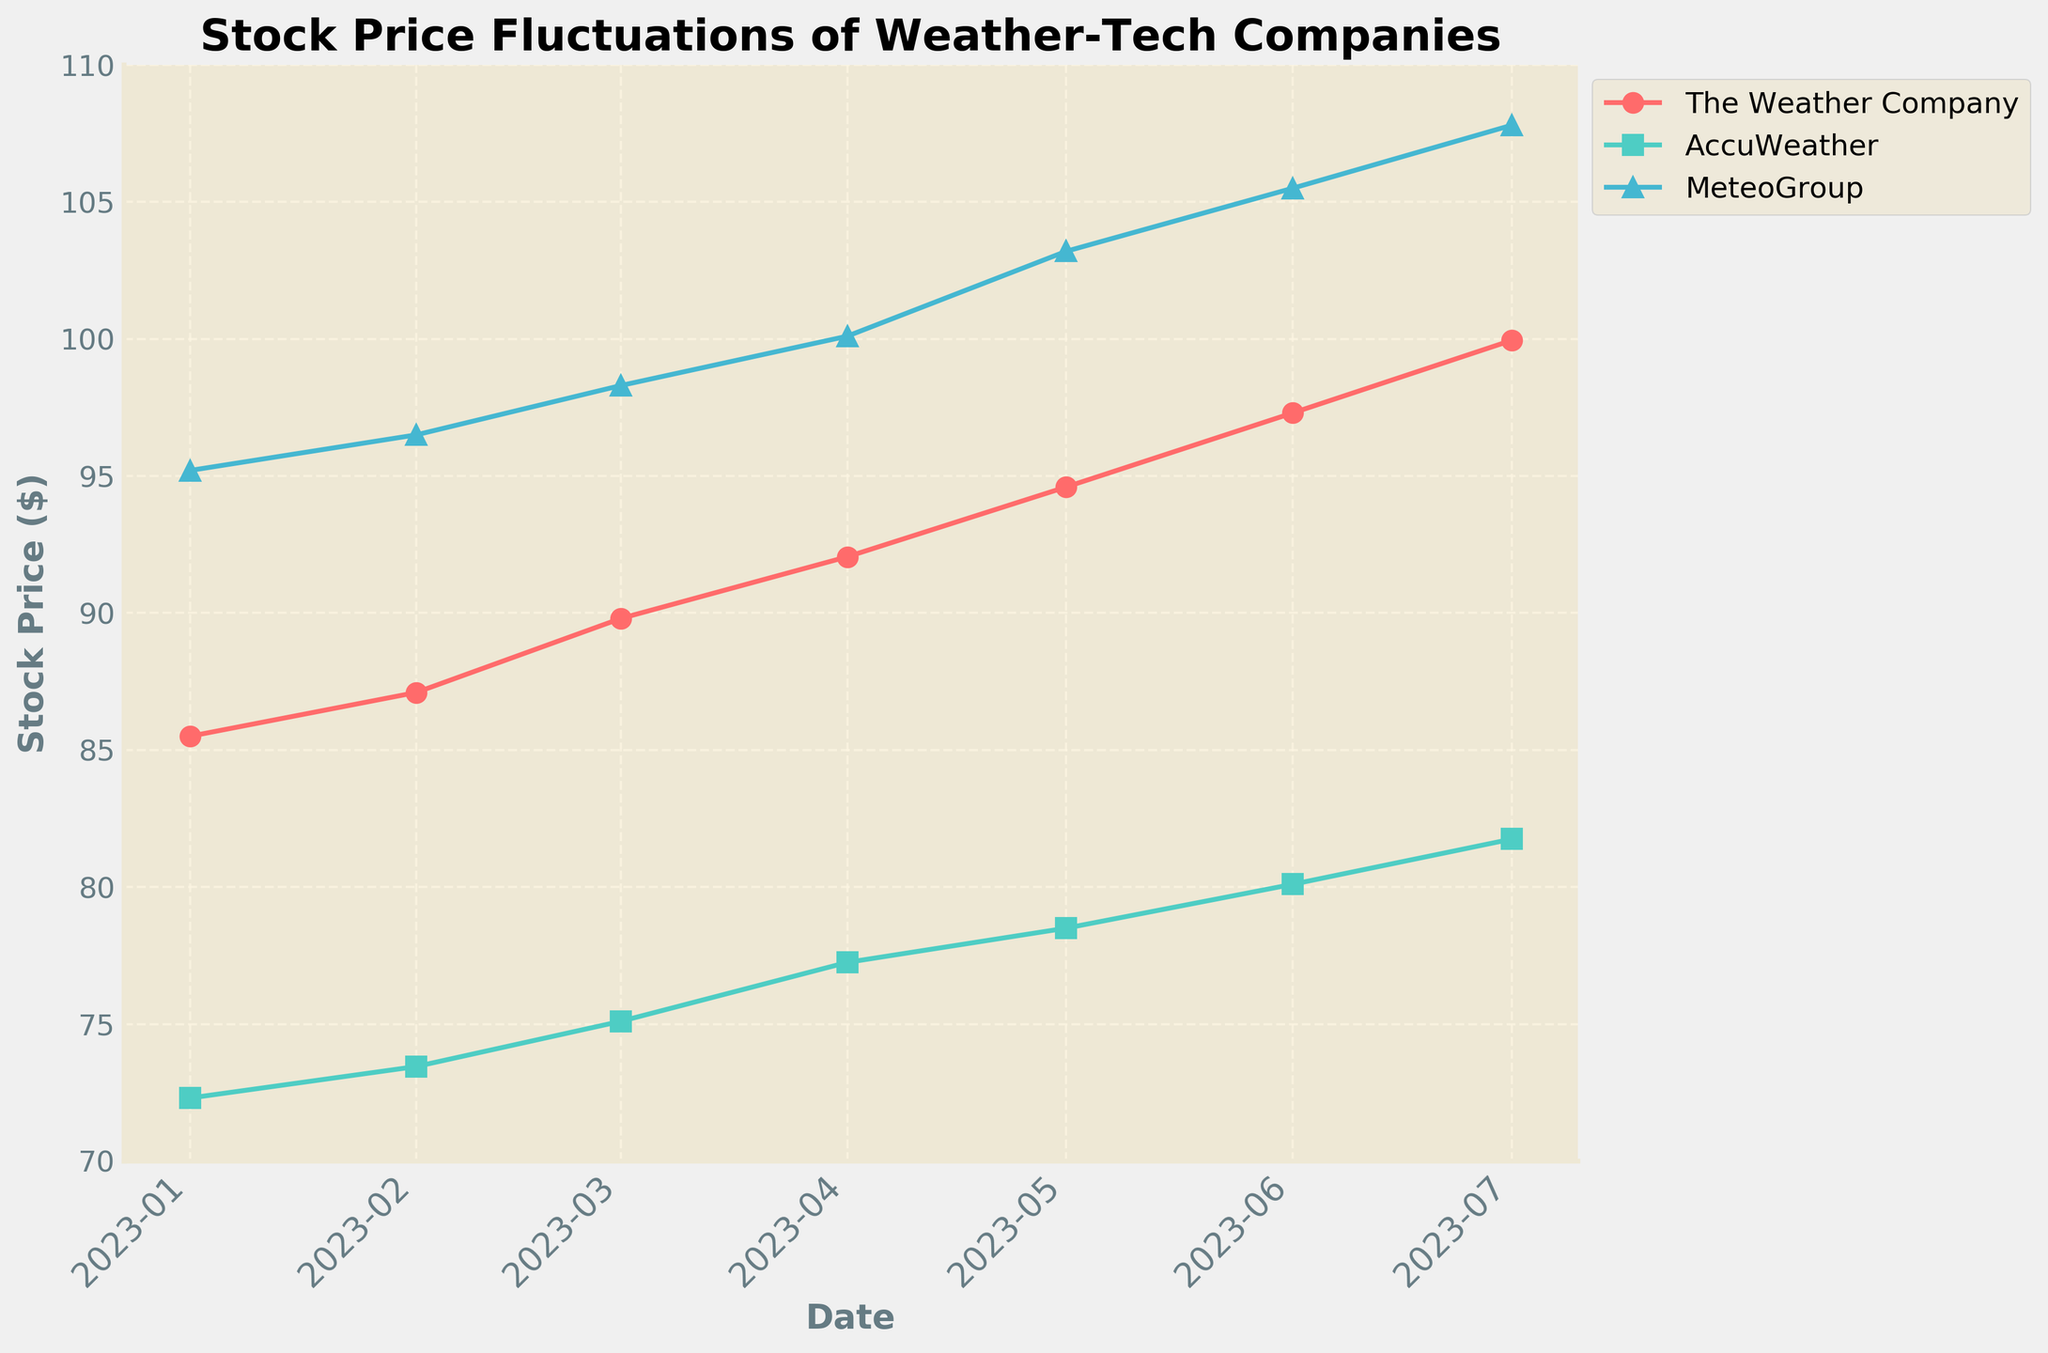What is the title of the plot? The title is typically prominently displayed at the top of the plot, allowing viewers to quickly understand what the plot depicts. Here, the title reads "Stock Price Fluctuations of Weather-Tech Companies."
Answer: Stock Price Fluctuations of Weather-Tech Companies What's the time range presented in the plot? By examining the x-axis, which displays dates, we can see that the plot starts at "2023-01-01" and ends at "2023-07-01."
Answer: January 2023 to July 2023 Which company had the highest stock price on June 1, 2023? By looking at the plotted data points for each company on June 1, 2023, we see that MeteoGroup had the highest stock price, at approximately $105.50.
Answer: MeteoGroup How many companies are represented in the plot? Three distinct lines, each labeled differently, represent three companies: The Weather Company, AccuWeather, and MeteoGroup.
Answer: Three Which company showed the most consistent increase in stock price over the period? By observing the slopes of the lines for each company, we can determine that MeteoGroup shows the most consistent increase, with an upward curve and the highest final value.
Answer: MeteoGroup What is the approximate stock price of AccuWeather in March 2023? Referencing the data points for AccuWeather in March 2023, the stock price was approximately $75.10.
Answer: $75.10 What was the difference in stock price for The Weather Company between January and July 2023? The Weather Company's stock price in January was $85.50 and in July was $99.95. The difference is $99.95 - $85.50 = $14.45.
Answer: $14.45 On which date did The Weather Company surpass a stock price of $90? The plot shows that The Weather Company surpassed a stock price of $90 in April 2023.
Answer: April 2023 Which company had the smallest increase in stock price over the period? By comparing the starting and ending prices for each company, AccuWeather had the smallest increase from $72.30 in January to $81.75 in July.
Answer: AccuWeather What's the average stock price of MeteoGroup across all the plotted dates? Summing the stock prices of MeteoGroup and dividing by the number of points: (95.20 + 96.50 + 98.30 + 100.10 + 103.20 + 105.50 + 107.80) / 7 = 101.23.
Answer: $101.23 